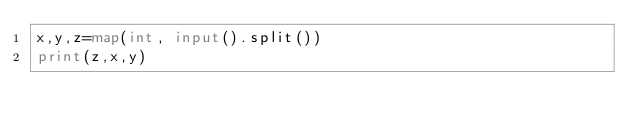Convert code to text. <code><loc_0><loc_0><loc_500><loc_500><_Python_>x,y,z=map(int, input().split())
print(z,x,y)</code> 